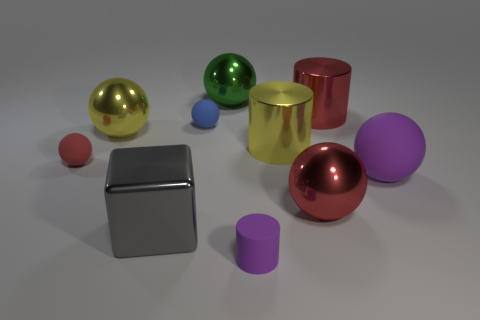Subtract all large metallic cylinders. How many cylinders are left? 1 Subtract all red cylinders. How many cylinders are left? 2 Subtract 0 gray cylinders. How many objects are left? 10 Subtract all balls. How many objects are left? 4 Subtract 3 spheres. How many spheres are left? 3 Subtract all green blocks. Subtract all cyan spheres. How many blocks are left? 1 Subtract all brown blocks. How many brown balls are left? 0 Subtract all tiny yellow rubber blocks. Subtract all big purple things. How many objects are left? 9 Add 9 big gray objects. How many big gray objects are left? 10 Add 5 big green shiny things. How many big green shiny things exist? 6 